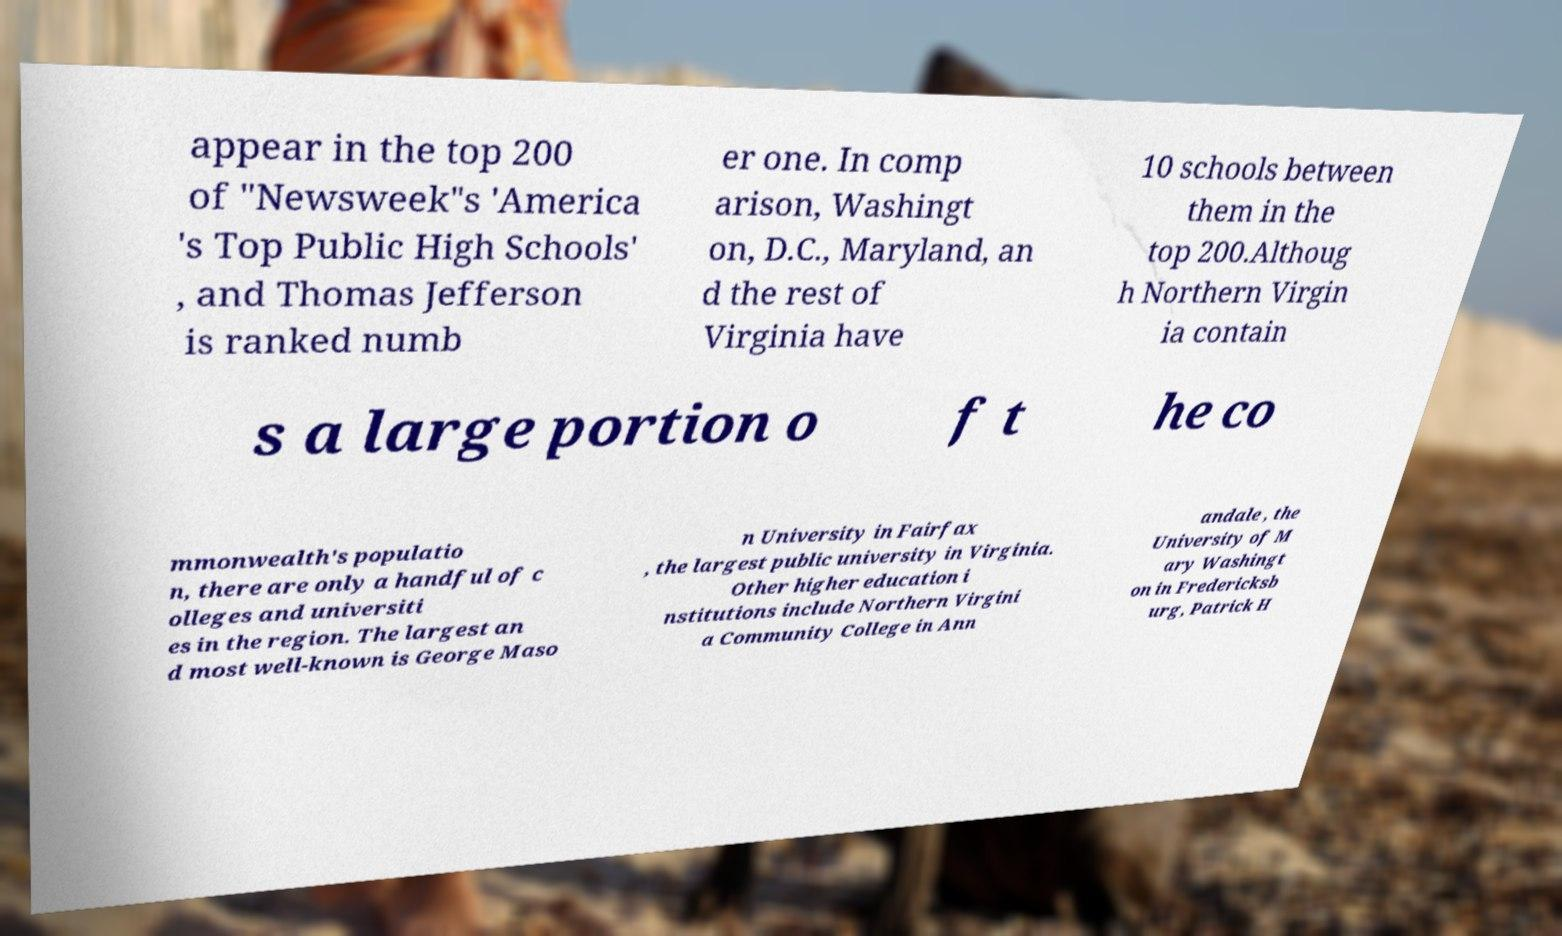For documentation purposes, I need the text within this image transcribed. Could you provide that? appear in the top 200 of "Newsweek"s 'America 's Top Public High Schools' , and Thomas Jefferson is ranked numb er one. In comp arison, Washingt on, D.C., Maryland, an d the rest of Virginia have 10 schools between them in the top 200.Althoug h Northern Virgin ia contain s a large portion o f t he co mmonwealth's populatio n, there are only a handful of c olleges and universiti es in the region. The largest an d most well-known is George Maso n University in Fairfax , the largest public university in Virginia. Other higher education i nstitutions include Northern Virgini a Community College in Ann andale , the University of M ary Washingt on in Fredericksb urg, Patrick H 